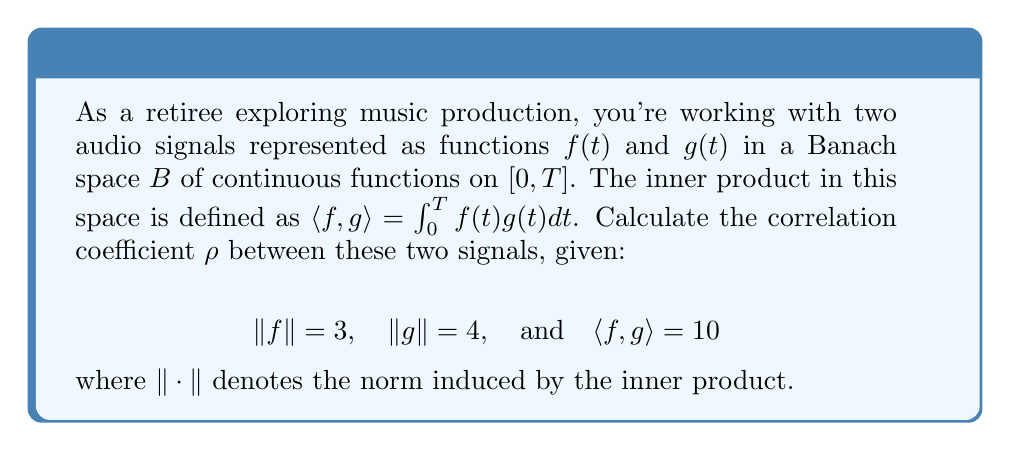Could you help me with this problem? Let's approach this step-by-step:

1) The correlation coefficient $\rho$ between two functions $f$ and $g$ in a Banach space is defined as:

   $$\rho = \frac{\langle f, g \rangle}{\|f\| \|g\|}$$

2) We are given:
   - $\|f\| = 3$
   - $\|g\| = 4$
   - $\langle f, g \rangle = 10$

3) Let's substitute these values into the formula:

   $$\rho = \frac{10}{3 \cdot 4}$$

4) Simplify:
   
   $$\rho = \frac{10}{12}$$

5) Reduce the fraction:

   $$\rho = \frac{5}{6}$$

This value of $\frac{5}{6}$ (approximately 0.833) indicates a strong positive correlation between the two audio signals.
Answer: $\frac{5}{6}$ 